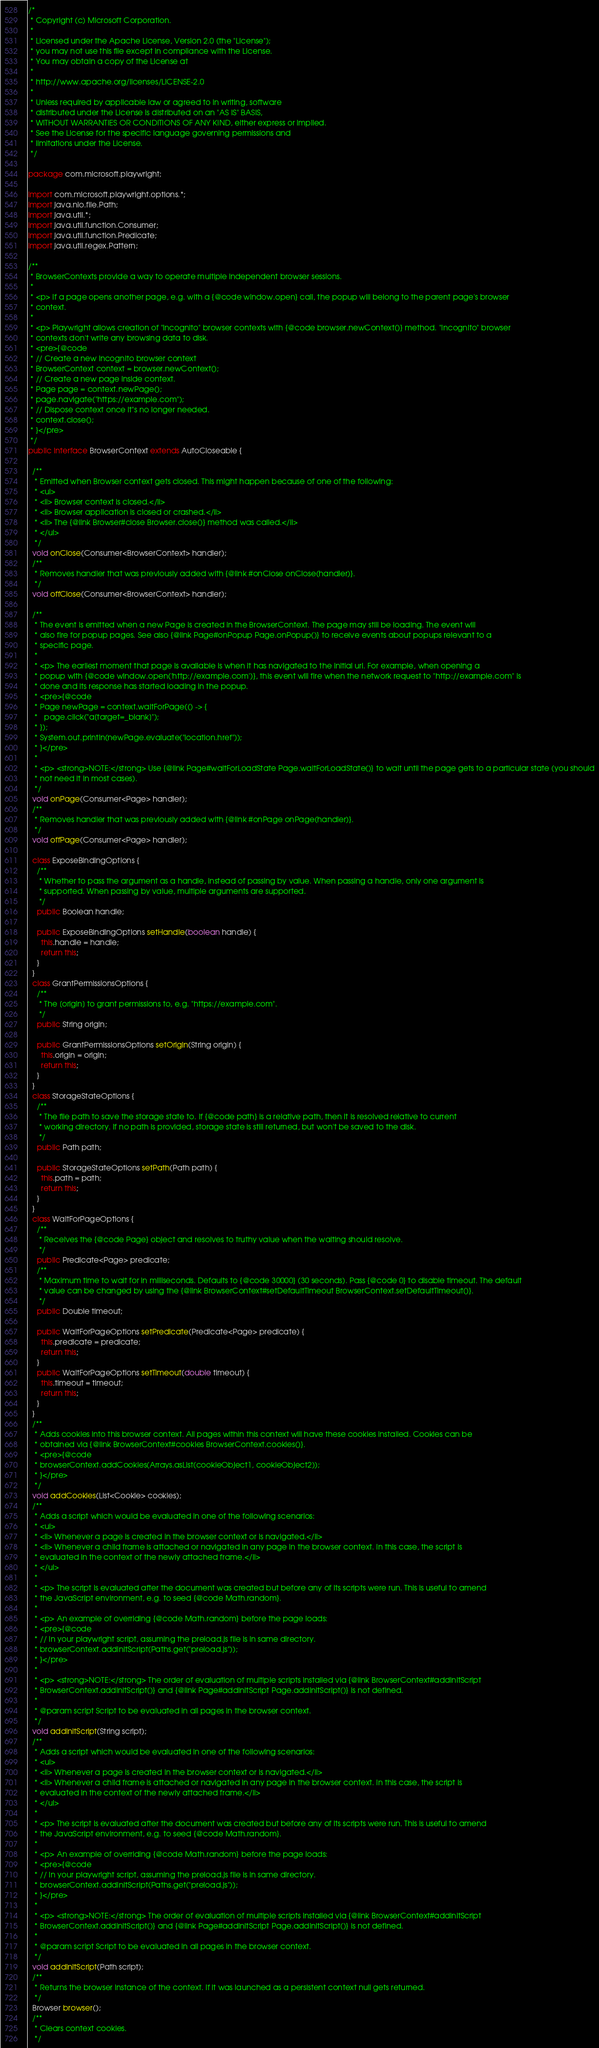<code> <loc_0><loc_0><loc_500><loc_500><_Java_>/*
 * Copyright (c) Microsoft Corporation.
 *
 * Licensed under the Apache License, Version 2.0 (the "License");
 * you may not use this file except in compliance with the License.
 * You may obtain a copy of the License at
 *
 * http://www.apache.org/licenses/LICENSE-2.0
 *
 * Unless required by applicable law or agreed to in writing, software
 * distributed under the License is distributed on an "AS IS" BASIS,
 * WITHOUT WARRANTIES OR CONDITIONS OF ANY KIND, either express or implied.
 * See the License for the specific language governing permissions and
 * limitations under the License.
 */

package com.microsoft.playwright;

import com.microsoft.playwright.options.*;
import java.nio.file.Path;
import java.util.*;
import java.util.function.Consumer;
import java.util.function.Predicate;
import java.util.regex.Pattern;

/**
 * BrowserContexts provide a way to operate multiple independent browser sessions.
 *
 * <p> If a page opens another page, e.g. with a {@code window.open} call, the popup will belong to the parent page's browser
 * context.
 *
 * <p> Playwright allows creation of "incognito" browser contexts with {@code browser.newContext()} method. "Incognito" browser
 * contexts don't write any browsing data to disk.
 * <pre>{@code
 * // Create a new incognito browser context
 * BrowserContext context = browser.newContext();
 * // Create a new page inside context.
 * Page page = context.newPage();
 * page.navigate("https://example.com");
 * // Dispose context once it"s no longer needed.
 * context.close();
 * }</pre>
 */
public interface BrowserContext extends AutoCloseable {

  /**
   * Emitted when Browser context gets closed. This might happen because of one of the following:
   * <ul>
   * <li> Browser context is closed.</li>
   * <li> Browser application is closed or crashed.</li>
   * <li> The {@link Browser#close Browser.close()} method was called.</li>
   * </ul>
   */
  void onClose(Consumer<BrowserContext> handler);
  /**
   * Removes handler that was previously added with {@link #onClose onClose(handler)}.
   */
  void offClose(Consumer<BrowserContext> handler);

  /**
   * The event is emitted when a new Page is created in the BrowserContext. The page may still be loading. The event will
   * also fire for popup pages. See also {@link Page#onPopup Page.onPopup()} to receive events about popups relevant to a
   * specific page.
   *
   * <p> The earliest moment that page is available is when it has navigated to the initial url. For example, when opening a
   * popup with {@code window.open('http://example.com')}, this event will fire when the network request to "http://example.com" is
   * done and its response has started loading in the popup.
   * <pre>{@code
   * Page newPage = context.waitForPage(() -> {
   *   page.click("a[target=_blank]");
   * });
   * System.out.println(newPage.evaluate("location.href"));
   * }</pre>
   *
   * <p> <strong>NOTE:</strong> Use {@link Page#waitForLoadState Page.waitForLoadState()} to wait until the page gets to a particular state (you should
   * not need it in most cases).
   */
  void onPage(Consumer<Page> handler);
  /**
   * Removes handler that was previously added with {@link #onPage onPage(handler)}.
   */
  void offPage(Consumer<Page> handler);

  class ExposeBindingOptions {
    /**
     * Whether to pass the argument as a handle, instead of passing by value. When passing a handle, only one argument is
     * supported. When passing by value, multiple arguments are supported.
     */
    public Boolean handle;

    public ExposeBindingOptions setHandle(boolean handle) {
      this.handle = handle;
      return this;
    }
  }
  class GrantPermissionsOptions {
    /**
     * The [origin] to grant permissions to, e.g. "https://example.com".
     */
    public String origin;

    public GrantPermissionsOptions setOrigin(String origin) {
      this.origin = origin;
      return this;
    }
  }
  class StorageStateOptions {
    /**
     * The file path to save the storage state to. If {@code path} is a relative path, then it is resolved relative to current
     * working directory. If no path is provided, storage state is still returned, but won't be saved to the disk.
     */
    public Path path;

    public StorageStateOptions setPath(Path path) {
      this.path = path;
      return this;
    }
  }
  class WaitForPageOptions {
    /**
     * Receives the {@code Page} object and resolves to truthy value when the waiting should resolve.
     */
    public Predicate<Page> predicate;
    /**
     * Maximum time to wait for in milliseconds. Defaults to {@code 30000} (30 seconds). Pass {@code 0} to disable timeout. The default
     * value can be changed by using the {@link BrowserContext#setDefaultTimeout BrowserContext.setDefaultTimeout()}.
     */
    public Double timeout;

    public WaitForPageOptions setPredicate(Predicate<Page> predicate) {
      this.predicate = predicate;
      return this;
    }
    public WaitForPageOptions setTimeout(double timeout) {
      this.timeout = timeout;
      return this;
    }
  }
  /**
   * Adds cookies into this browser context. All pages within this context will have these cookies installed. Cookies can be
   * obtained via {@link BrowserContext#cookies BrowserContext.cookies()}.
   * <pre>{@code
   * browserContext.addCookies(Arrays.asList(cookieObject1, cookieObject2));
   * }</pre>
   */
  void addCookies(List<Cookie> cookies);
  /**
   * Adds a script which would be evaluated in one of the following scenarios:
   * <ul>
   * <li> Whenever a page is created in the browser context or is navigated.</li>
   * <li> Whenever a child frame is attached or navigated in any page in the browser context. In this case, the script is
   * evaluated in the context of the newly attached frame.</li>
   * </ul>
   *
   * <p> The script is evaluated after the document was created but before any of its scripts were run. This is useful to amend
   * the JavaScript environment, e.g. to seed {@code Math.random}.
   *
   * <p> An example of overriding {@code Math.random} before the page loads:
   * <pre>{@code
   * // In your playwright script, assuming the preload.js file is in same directory.
   * browserContext.addInitScript(Paths.get("preload.js"));
   * }</pre>
   *
   * <p> <strong>NOTE:</strong> The order of evaluation of multiple scripts installed via {@link BrowserContext#addInitScript
   * BrowserContext.addInitScript()} and {@link Page#addInitScript Page.addInitScript()} is not defined.
   *
   * @param script Script to be evaluated in all pages in the browser context.
   */
  void addInitScript(String script);
  /**
   * Adds a script which would be evaluated in one of the following scenarios:
   * <ul>
   * <li> Whenever a page is created in the browser context or is navigated.</li>
   * <li> Whenever a child frame is attached or navigated in any page in the browser context. In this case, the script is
   * evaluated in the context of the newly attached frame.</li>
   * </ul>
   *
   * <p> The script is evaluated after the document was created but before any of its scripts were run. This is useful to amend
   * the JavaScript environment, e.g. to seed {@code Math.random}.
   *
   * <p> An example of overriding {@code Math.random} before the page loads:
   * <pre>{@code
   * // In your playwright script, assuming the preload.js file is in same directory.
   * browserContext.addInitScript(Paths.get("preload.js"));
   * }</pre>
   *
   * <p> <strong>NOTE:</strong> The order of evaluation of multiple scripts installed via {@link BrowserContext#addInitScript
   * BrowserContext.addInitScript()} and {@link Page#addInitScript Page.addInitScript()} is not defined.
   *
   * @param script Script to be evaluated in all pages in the browser context.
   */
  void addInitScript(Path script);
  /**
   * Returns the browser instance of the context. If it was launched as a persistent context null gets returned.
   */
  Browser browser();
  /**
   * Clears context cookies.
   */</code> 